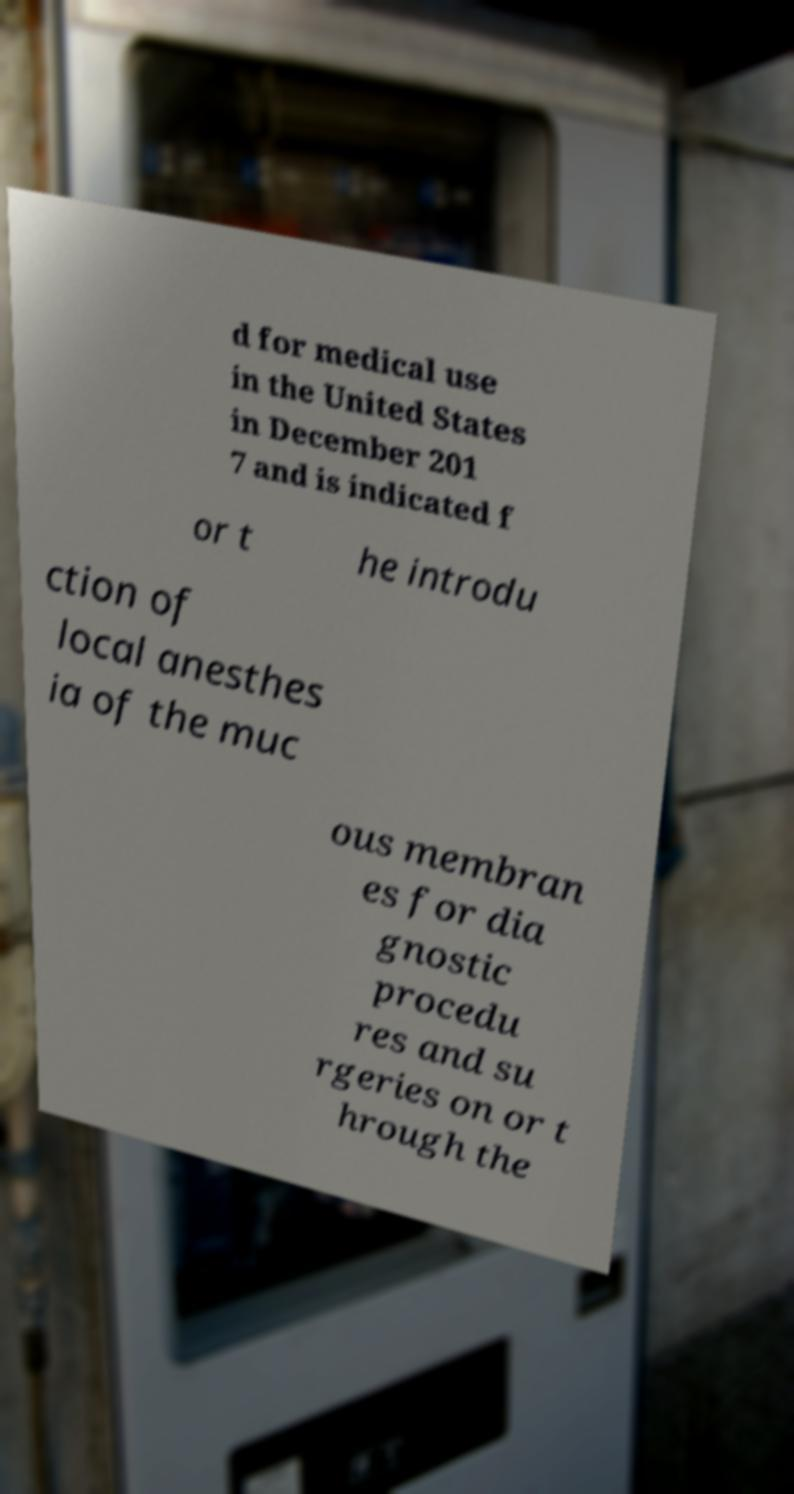Can you read and provide the text displayed in the image?This photo seems to have some interesting text. Can you extract and type it out for me? d for medical use in the United States in December 201 7 and is indicated f or t he introdu ction of local anesthes ia of the muc ous membran es for dia gnostic procedu res and su rgeries on or t hrough the 